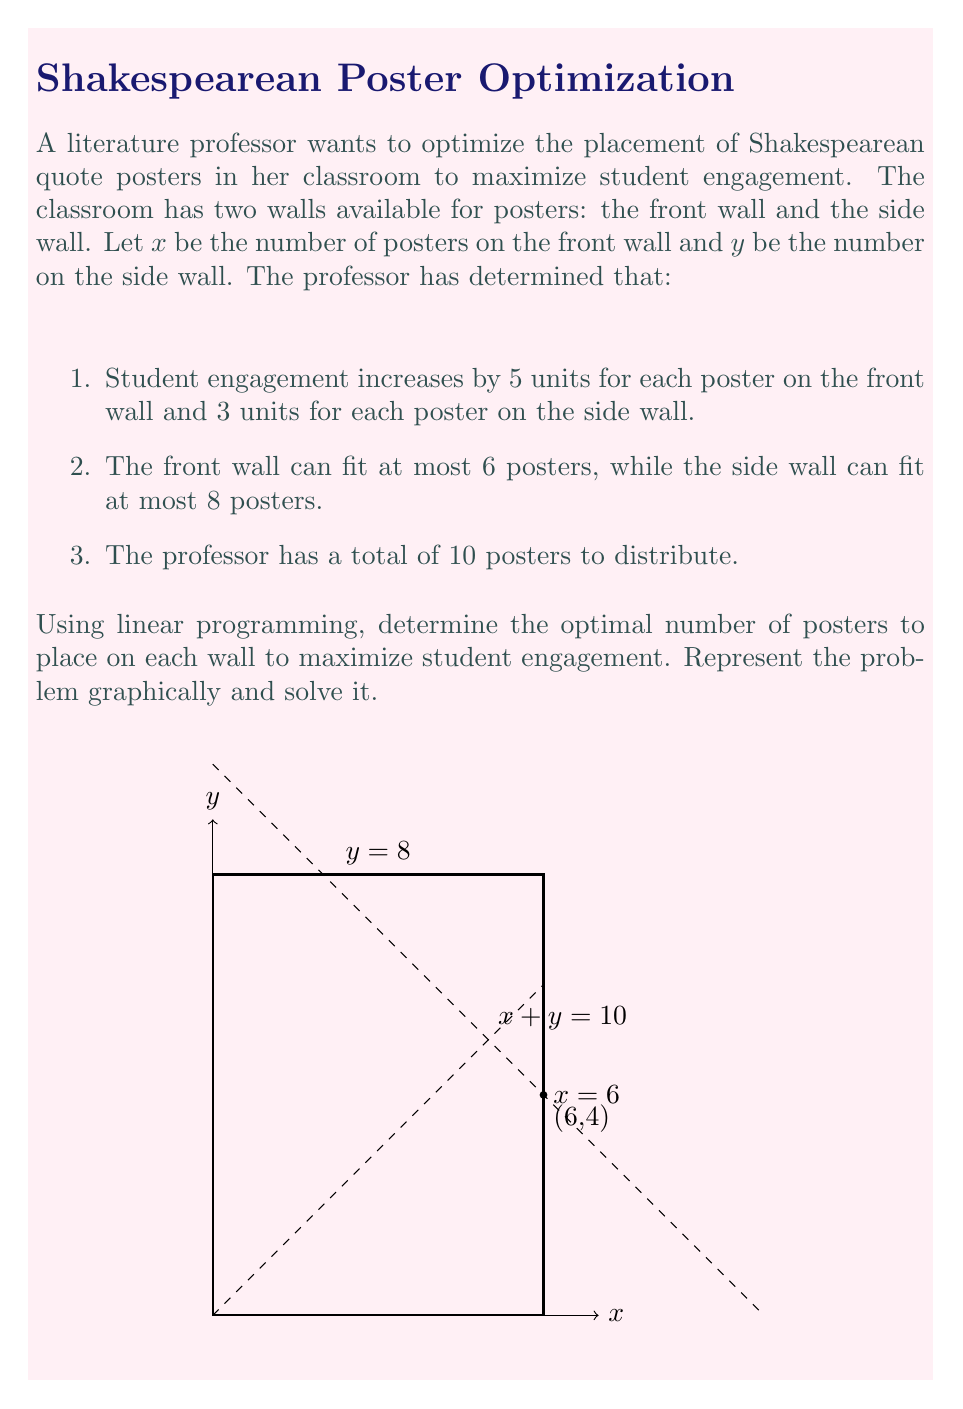What is the answer to this math problem? Let's approach this step-by-step using linear programming:

1) First, we define our objective function. We want to maximize student engagement:
   $$\text{Maximize } Z = 5x + 3y$$

2) Now, we list our constraints:
   $$x \leq 6$$ (front wall capacity)
   $$y \leq 8$$ (side wall capacity)
   $$x + y \leq 10$$ (total number of posters)
   $$x \geq 0, y \geq 0$$ (non-negativity constraints)

3) We can solve this graphically. The feasible region is bounded by the lines:
   $x = 6$, $y = 8$, $x + y = 10$, and the x and y axes.

4) The optimal solution will be at one of the corner points of this feasible region. The corner points are:
   (0,0), (6,0), (6,4), (2,8), (0,8)

5) We evaluate our objective function at each point:
   (0,0): $Z = 0$
   (6,0): $Z = 30$
   (6,4): $Z = 42$
   (2,8): $Z = 34$
   (0,8): $Z = 24$

6) The maximum value occurs at the point (6,4), which gives us $Z = 42$.

Therefore, the optimal solution is to place 6 posters on the front wall and 4 posters on the side wall.
Answer: 6 posters on the front wall, 4 on the side wall. 